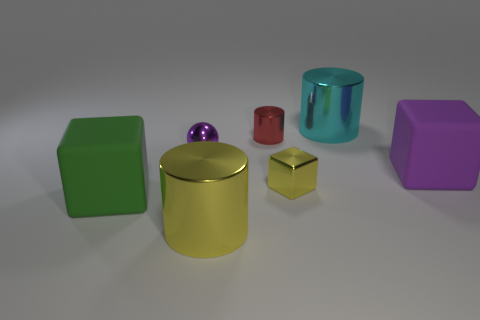Add 2 tiny yellow metallic cubes. How many objects exist? 9 Subtract all cylinders. How many objects are left? 4 Add 1 spheres. How many spheres exist? 2 Subtract 0 brown cylinders. How many objects are left? 7 Subtract all blue shiny blocks. Subtract all large yellow metallic cylinders. How many objects are left? 6 Add 6 big yellow cylinders. How many big yellow cylinders are left? 7 